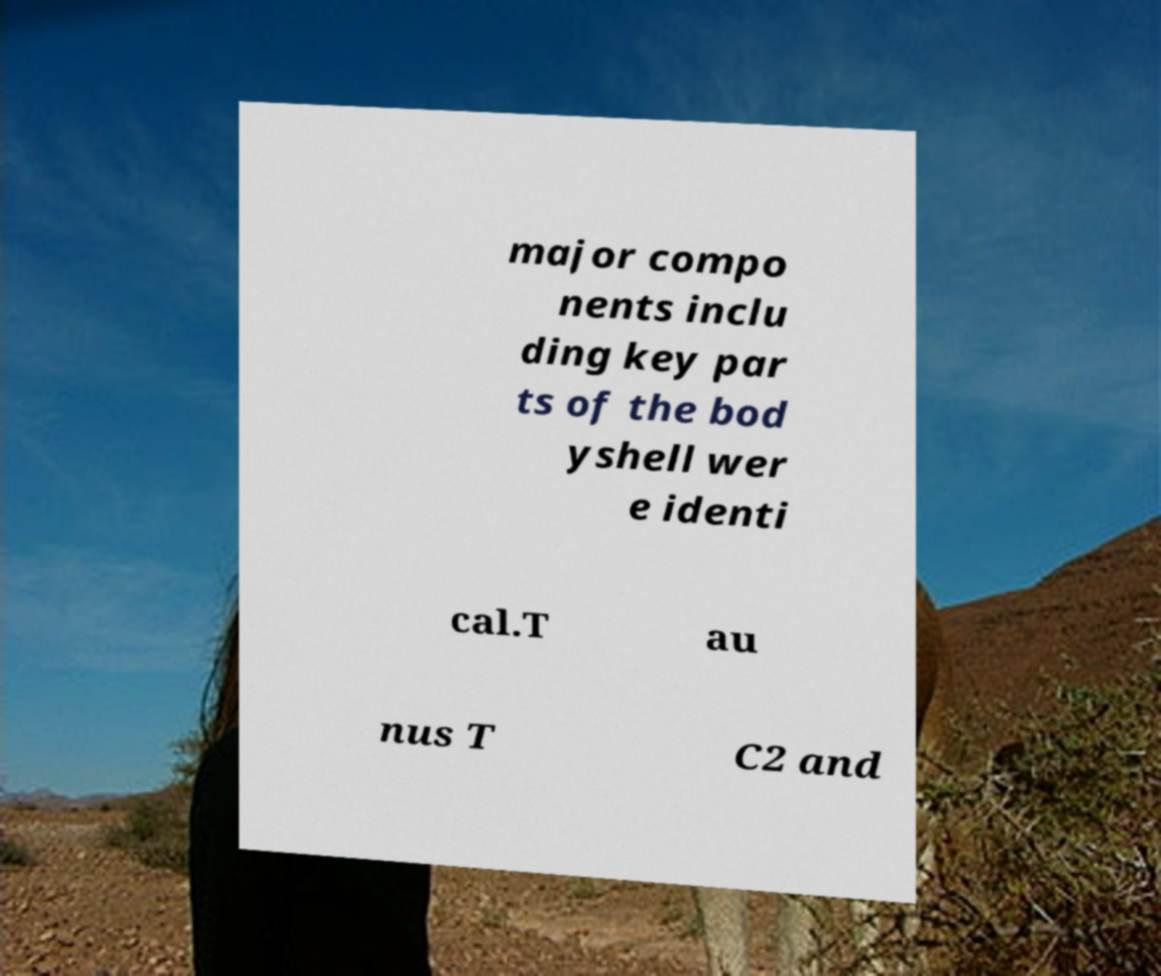Can you read and provide the text displayed in the image?This photo seems to have some interesting text. Can you extract and type it out for me? major compo nents inclu ding key par ts of the bod yshell wer e identi cal.T au nus T C2 and 